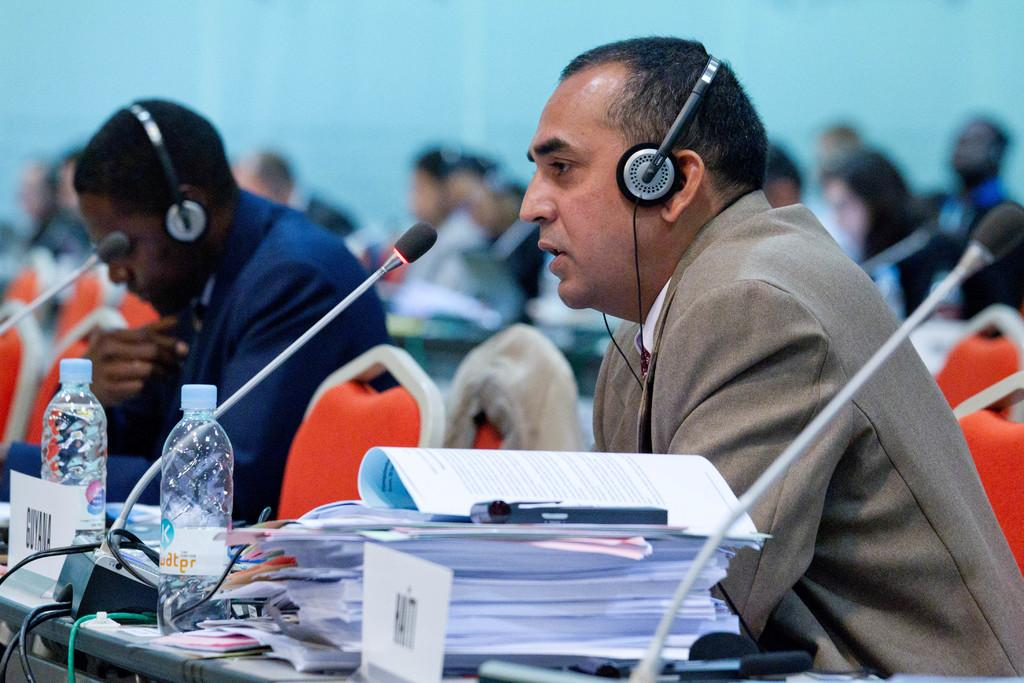What are the people in the image doing? The people in the image are sitting on chairs. What are the people wearing while sitting on the chairs? The people are wearing headphones. What items can be seen in the image besides the people and chairs? There are books, microphones, and bottles in the image. What is present on the table in the image? There are objects on a table in the image. How would you describe the background of the image? The background of the image is blurry. What type of arch can be seen in the image? There is no arch present in the image. What is the ice doing in the image? There is no ice present in the image. 